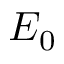Convert formula to latex. <formula><loc_0><loc_0><loc_500><loc_500>E _ { 0 }</formula> 